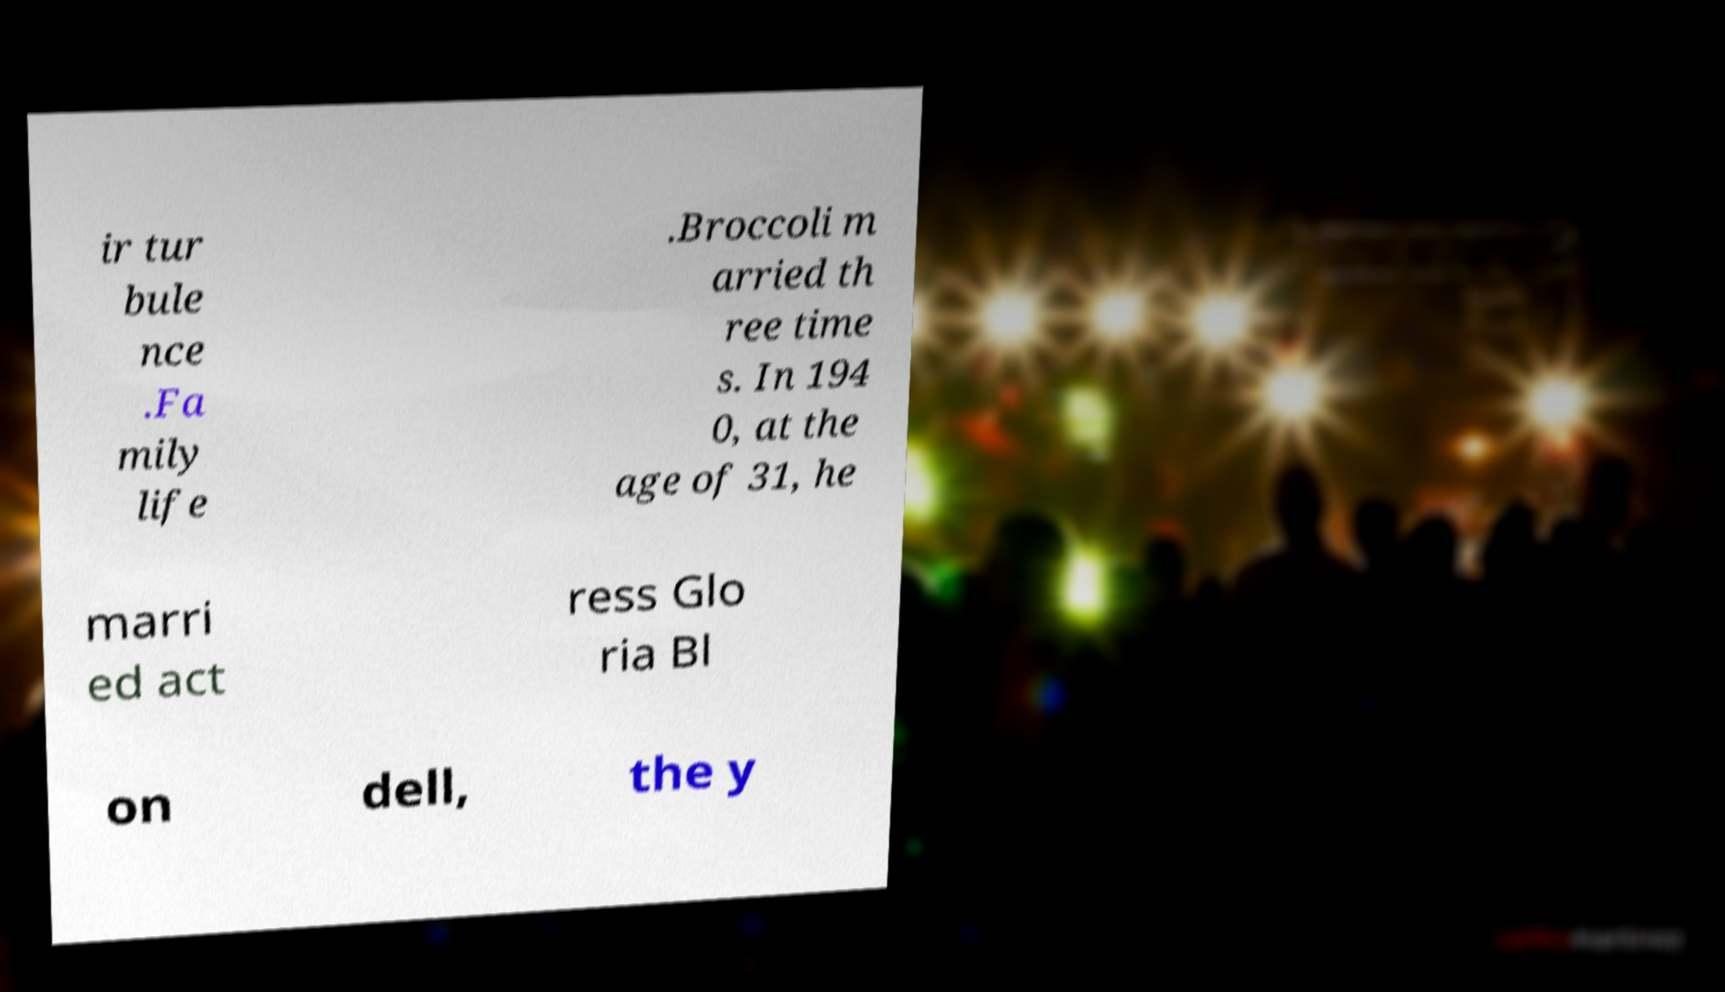Could you assist in decoding the text presented in this image and type it out clearly? ir tur bule nce .Fa mily life .Broccoli m arried th ree time s. In 194 0, at the age of 31, he marri ed act ress Glo ria Bl on dell, the y 